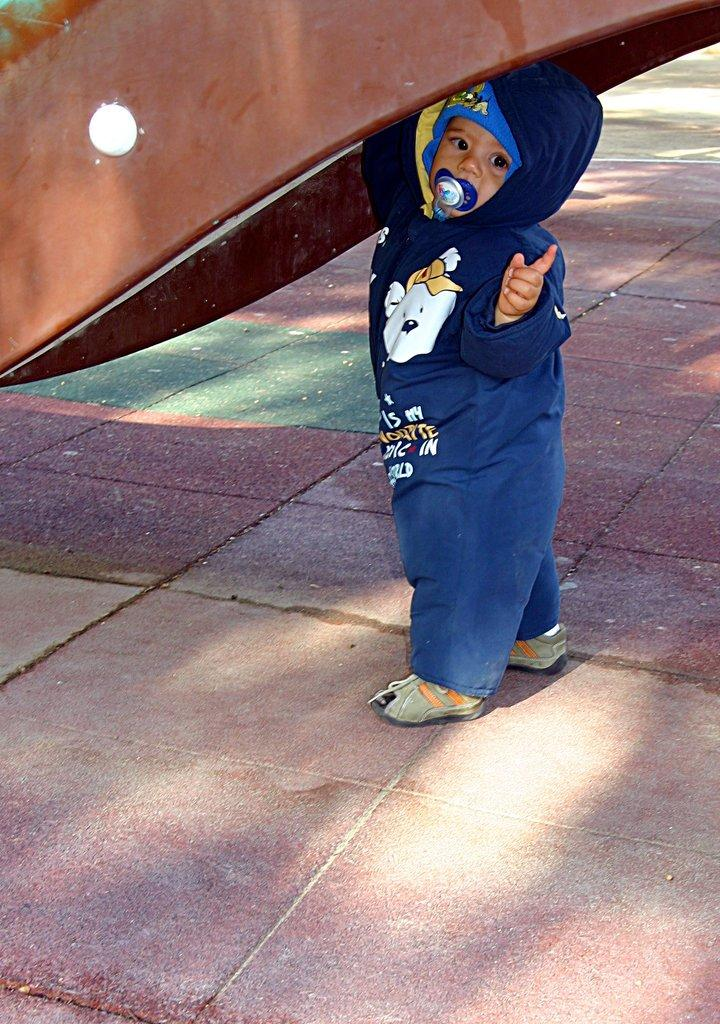What is the main subject of the image? The main subject of the image is a kid. Where is the kid located in the image? The kid is standing on the floor. What type of sun can be seen in the image? There is no sun visible in the image. 